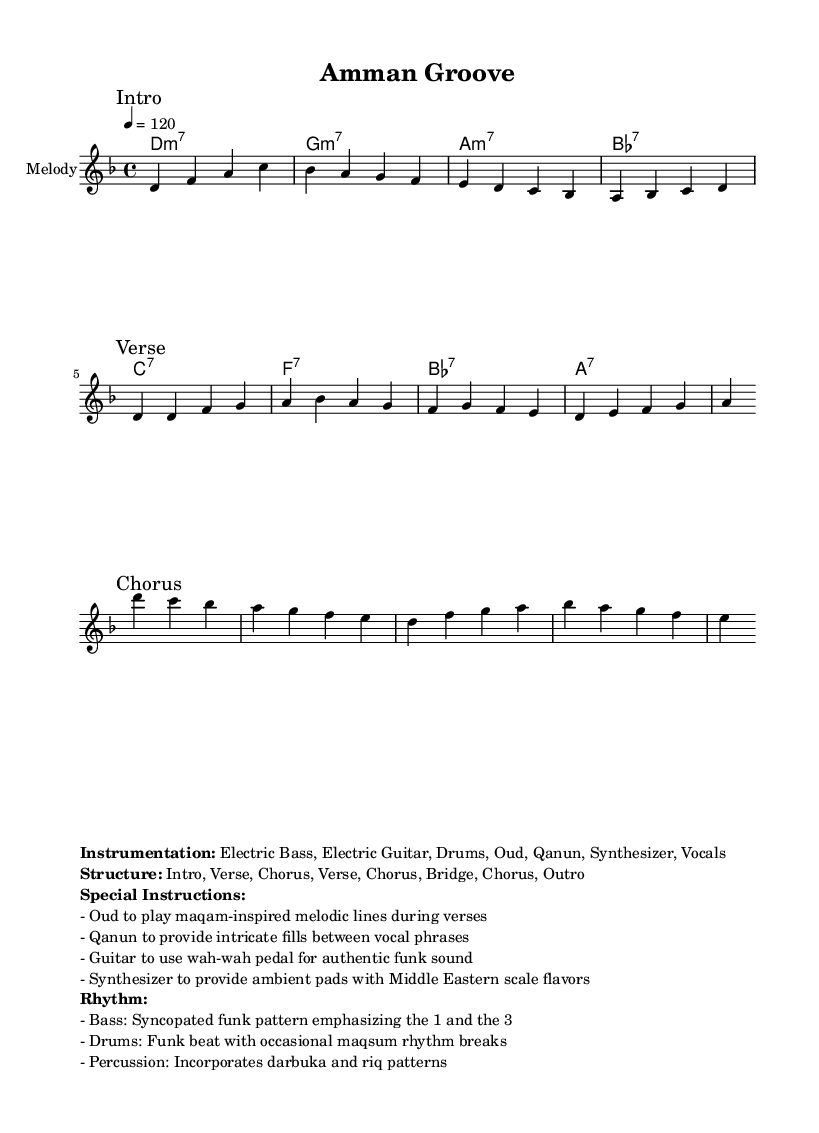What is the key signature of this music? The key signature is D minor, which has one flat (B flat) noted at the start of the staff.
Answer: D minor What is the time signature of this piece? The time signature is 4/4, which means there are four beats in each measure and the quarter note receives one beat. This is indicated at the beginning of the piece.
Answer: 4/4 What is the tempo marking of this composition? The tempo marking is given as a quarter note equals 120, indicating the speed at which the music should be performed.
Answer: 120 How many unique sections are there in the structure of the piece? The structure listed indicates that there are five distinct sections: Intro, Verse, Chorus, Bridge, and Outro, noted under "Structure." Counting them gives a total of five unique sections.
Answer: 5 What instruments are included in the instrumentation for this piece? The instrumentation is detailed in the markup section and includes Electric Bass, Electric Guitar, Drums, Oud, Qanun, Synthesizer, and Vocals. This lists all the instruments involved in the performance.
Answer: Electric Bass, Electric Guitar, Drums, Oud, Qanun, Synthesizer, Vocals What rhythm pattern does the bass follow? The rhythm for the bass guitar is described as a syncopated funk pattern, emphasizing the 1 and the 3 beats in the measure. This distinction is crucial in funk genres to create groove and drive.
Answer: Syncopated funk pattern Which mode should the Oud play during the verses? The special instruction mentions the Oud should play maqam-inspired melodic lines during the verses to incorporate local musical traditions into the funk fusion style.
Answer: Maqam 